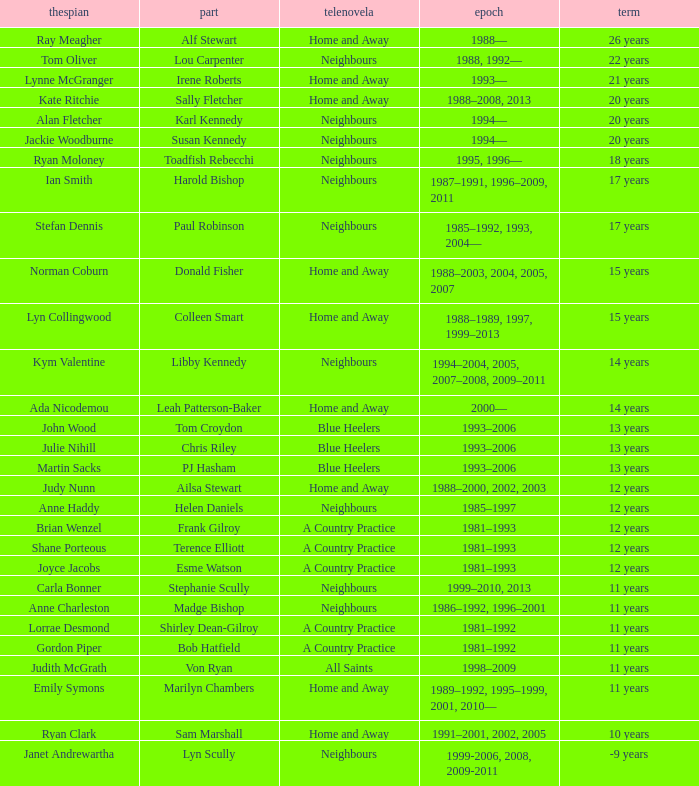Which years did Martin Sacks work on a soap opera? 1993–2006. Would you be able to parse every entry in this table? {'header': ['thespian', 'part', 'telenovela', 'epoch', 'term'], 'rows': [['Ray Meagher', 'Alf Stewart', 'Home and Away', '1988—', '26 years'], ['Tom Oliver', 'Lou Carpenter', 'Neighbours', '1988, 1992—', '22 years'], ['Lynne McGranger', 'Irene Roberts', 'Home and Away', '1993—', '21 years'], ['Kate Ritchie', 'Sally Fletcher', 'Home and Away', '1988–2008, 2013', '20 years'], ['Alan Fletcher', 'Karl Kennedy', 'Neighbours', '1994—', '20 years'], ['Jackie Woodburne', 'Susan Kennedy', 'Neighbours', '1994—', '20 years'], ['Ryan Moloney', 'Toadfish Rebecchi', 'Neighbours', '1995, 1996—', '18 years'], ['Ian Smith', 'Harold Bishop', 'Neighbours', '1987–1991, 1996–2009, 2011', '17 years'], ['Stefan Dennis', 'Paul Robinson', 'Neighbours', '1985–1992, 1993, 2004—', '17 years'], ['Norman Coburn', 'Donald Fisher', 'Home and Away', '1988–2003, 2004, 2005, 2007', '15 years'], ['Lyn Collingwood', 'Colleen Smart', 'Home and Away', '1988–1989, 1997, 1999–2013', '15 years'], ['Kym Valentine', 'Libby Kennedy', 'Neighbours', '1994–2004, 2005, 2007–2008, 2009–2011', '14 years'], ['Ada Nicodemou', 'Leah Patterson-Baker', 'Home and Away', '2000—', '14 years'], ['John Wood', 'Tom Croydon', 'Blue Heelers', '1993–2006', '13 years'], ['Julie Nihill', 'Chris Riley', 'Blue Heelers', '1993–2006', '13 years'], ['Martin Sacks', 'PJ Hasham', 'Blue Heelers', '1993–2006', '13 years'], ['Judy Nunn', 'Ailsa Stewart', 'Home and Away', '1988–2000, 2002, 2003', '12 years'], ['Anne Haddy', 'Helen Daniels', 'Neighbours', '1985–1997', '12 years'], ['Brian Wenzel', 'Frank Gilroy', 'A Country Practice', '1981–1993', '12 years'], ['Shane Porteous', 'Terence Elliott', 'A Country Practice', '1981–1993', '12 years'], ['Joyce Jacobs', 'Esme Watson', 'A Country Practice', '1981–1993', '12 years'], ['Carla Bonner', 'Stephanie Scully', 'Neighbours', '1999–2010, 2013', '11 years'], ['Anne Charleston', 'Madge Bishop', 'Neighbours', '1986–1992, 1996–2001', '11 years'], ['Lorrae Desmond', 'Shirley Dean-Gilroy', 'A Country Practice', '1981–1992', '11 years'], ['Gordon Piper', 'Bob Hatfield', 'A Country Practice', '1981–1992', '11 years'], ['Judith McGrath', 'Von Ryan', 'All Saints', '1998–2009', '11 years'], ['Emily Symons', 'Marilyn Chambers', 'Home and Away', '1989–1992, 1995–1999, 2001, 2010—', '11 years'], ['Ryan Clark', 'Sam Marshall', 'Home and Away', '1991–2001, 2002, 2005', '10 years'], ['Janet Andrewartha', 'Lyn Scully', 'Neighbours', '1999-2006, 2008, 2009-2011', '-9 years']]} 